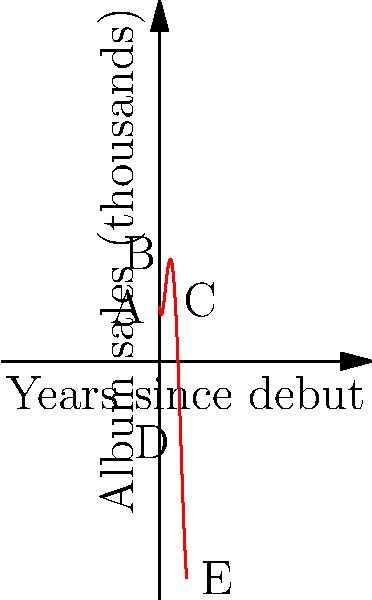The graph represents your album sales (in thousands) over the years since your debut, inspired by Yinka's career trajectory. Which point on the graph likely represents the peak of your popularity, similar to when Yinka released their breakthrough hit? To answer this question, we need to analyze the shape of the polynomial graph and understand what each point represents:

1. Point A: This is at the start of your career (0 years). Sales are moderate, typical for a debut album.

2. Point B: There's a slight dip here, possibly representing a sophomore slump or a period of reduced visibility.

3. Point C: This is the highest point on the graph. It represents the peak of your album sales, likely coinciding with your most popular and successful period. This would be similar to when Yinka released their breakthrough hit.

4. Point D: There's a decline after the peak, which is common in many music careers as the initial hype dies down.

5. Point E: There's a slight upturn at the end, possibly representing a resurgence in popularity or a successful comeback.

Given that we're looking for the point that represents the peak of your popularity, similar to Yinka's breakthrough, we should choose the highest point on the graph.
Answer: C 